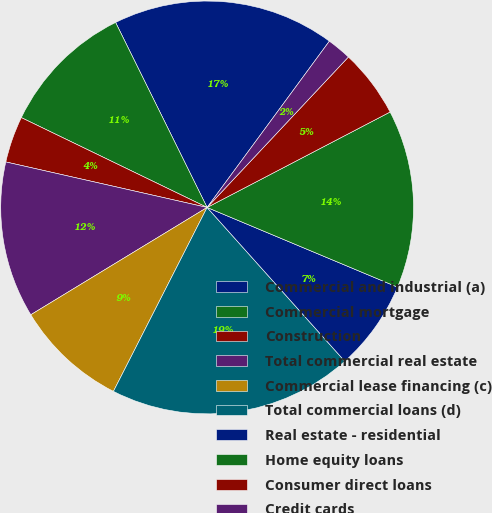Convert chart to OTSL. <chart><loc_0><loc_0><loc_500><loc_500><pie_chart><fcel>Commercial and industrial (a)<fcel>Commercial mortgage<fcel>Construction<fcel>Total commercial real estate<fcel>Commercial lease financing (c)<fcel>Total commercial loans (d)<fcel>Real estate - residential<fcel>Home equity loans<fcel>Consumer direct loans<fcel>Credit cards<nl><fcel>17.4%<fcel>10.52%<fcel>3.63%<fcel>12.24%<fcel>8.8%<fcel>19.12%<fcel>7.07%<fcel>13.96%<fcel>5.35%<fcel>1.91%<nl></chart> 